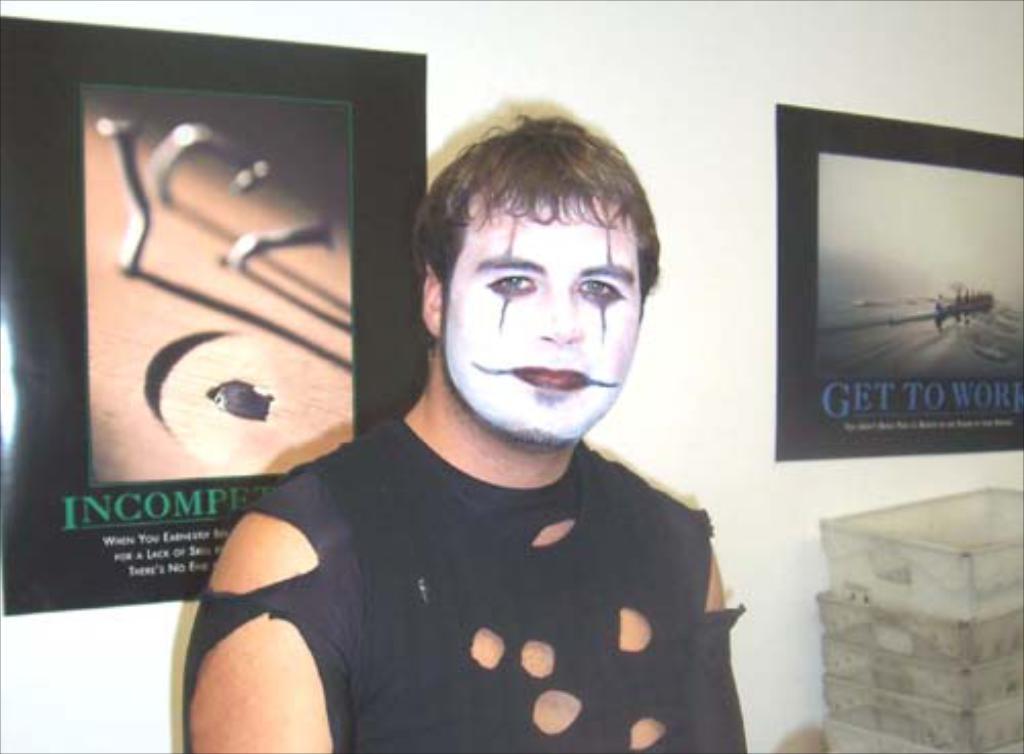Could you give a brief overview of what you see in this image? In this image I can see there is a man standing and he is wearing a torn shirt and there is a painting on his face. In the background there are photo frames placed on the wall. 